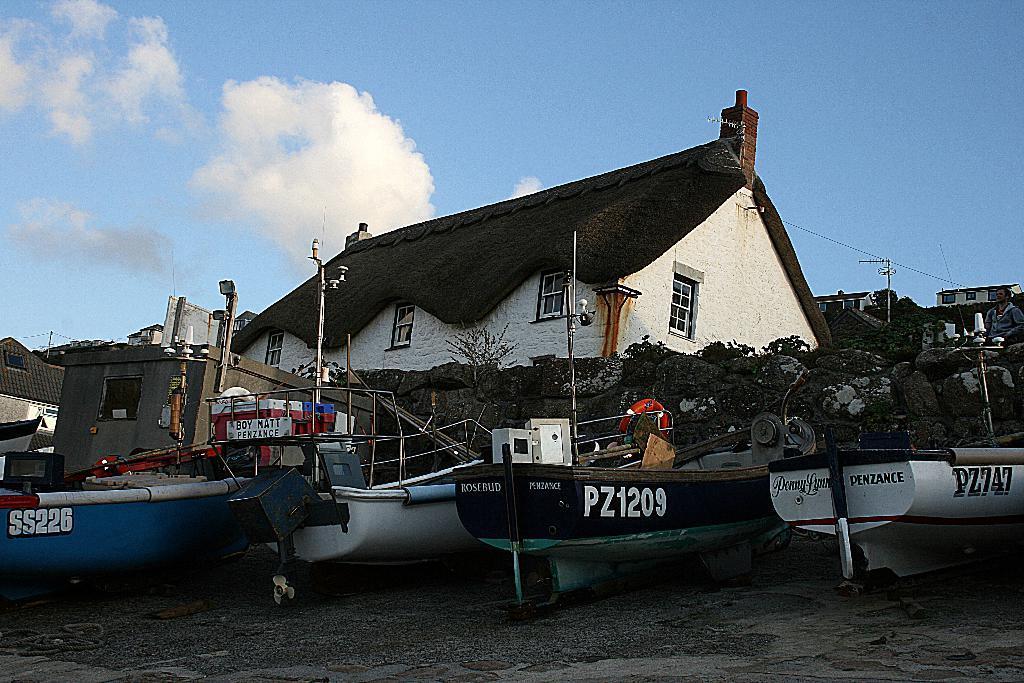In one or two sentences, can you explain what this image depicts? In this image on the water body there are boats. In the background there are buildings, trees. The sky is cloudy. 